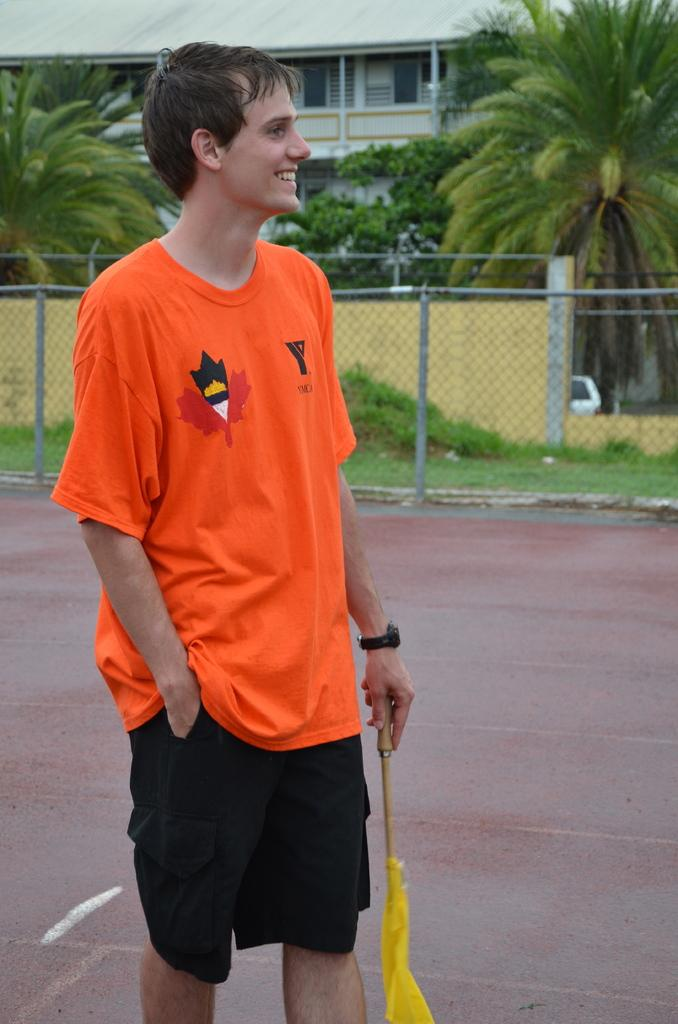What is the main subject of the image? There is a person in the image. What is the person wearing? The person is wearing a T-shirt. What is the person holding in the image? The person is holding a flag. What can be seen in the background of the image? There is a house, trees, and fencing in the background of the image. What is visible at the bottom of the image? There is a floor visible at the bottom of the image. What type of spark can be seen coming from the person's hand in the image? There is no spark visible in the image; the person is holding a flag. What type of secretary is present in the image? There is no secretary present in the image; it features a person holding a flag. 